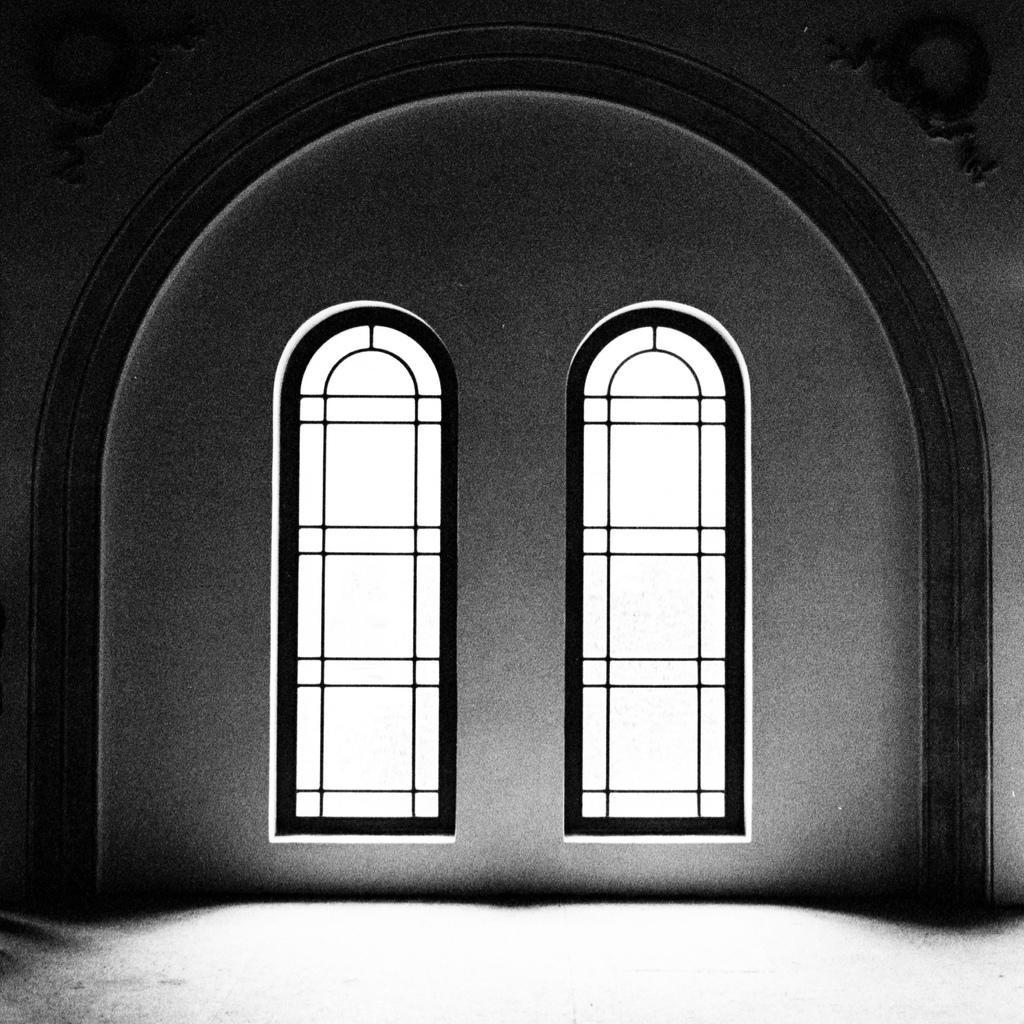How would you summarize this image in a sentence or two? This image is taken in the building. In the center of the image we can see windows and there is a wall. 